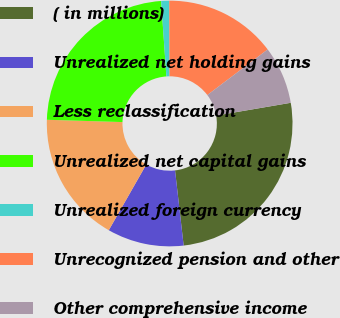Convert chart to OTSL. <chart><loc_0><loc_0><loc_500><loc_500><pie_chart><fcel>( in millions)<fcel>Unrealized net holding gains<fcel>Less reclassification<fcel>Unrealized net capital gains<fcel>Unrealized foreign currency<fcel>Unrecognized pension and other<fcel>Other comprehensive income<nl><fcel>25.88%<fcel>10.07%<fcel>17.23%<fcel>23.41%<fcel>1.05%<fcel>14.76%<fcel>7.6%<nl></chart> 